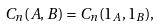<formula> <loc_0><loc_0><loc_500><loc_500>C _ { n } ( A , B ) = C _ { n } ( 1 _ { A } , 1 _ { B } ) ,</formula> 